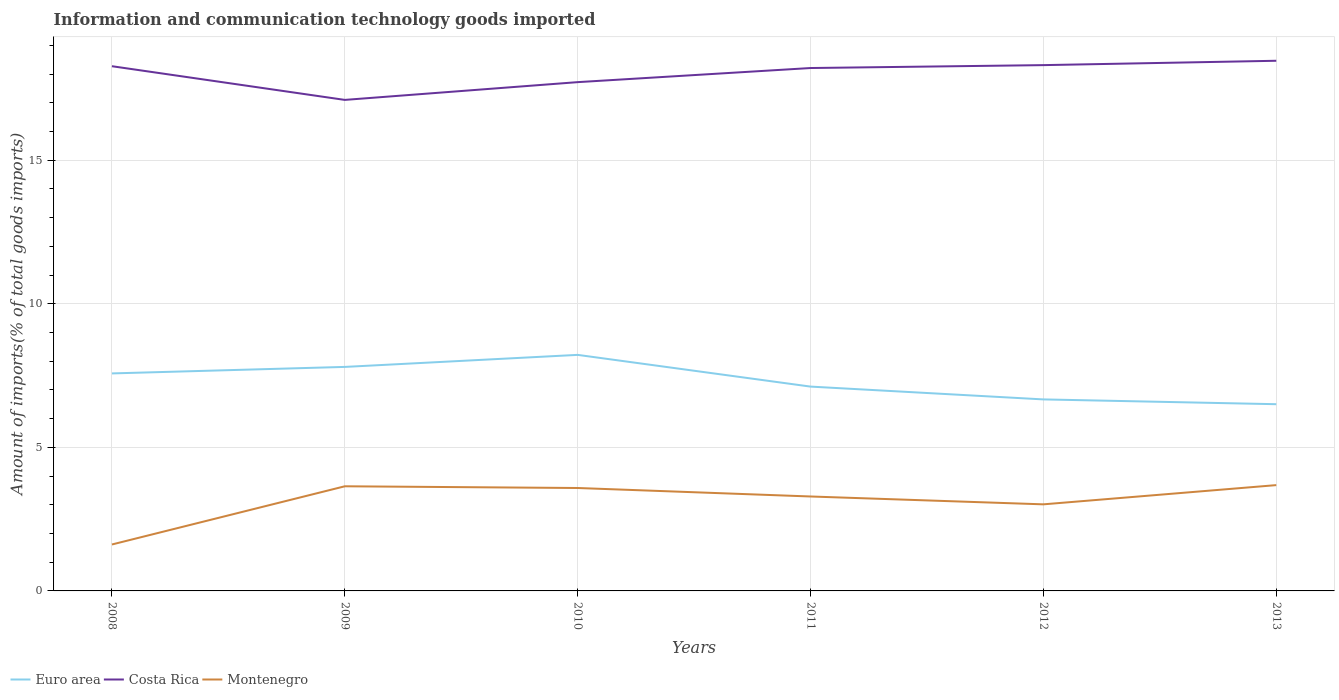How many different coloured lines are there?
Your response must be concise. 3. Does the line corresponding to Euro area intersect with the line corresponding to Costa Rica?
Make the answer very short. No. Across all years, what is the maximum amount of goods imported in Montenegro?
Give a very brief answer. 1.62. What is the total amount of goods imported in Montenegro in the graph?
Keep it short and to the point. 0.63. What is the difference between the highest and the second highest amount of goods imported in Montenegro?
Your answer should be compact. 2.07. Are the values on the major ticks of Y-axis written in scientific E-notation?
Offer a very short reply. No. Does the graph contain any zero values?
Ensure brevity in your answer.  No. Does the graph contain grids?
Provide a succinct answer. Yes. Where does the legend appear in the graph?
Your response must be concise. Bottom left. How are the legend labels stacked?
Provide a short and direct response. Horizontal. What is the title of the graph?
Give a very brief answer. Information and communication technology goods imported. Does "Guam" appear as one of the legend labels in the graph?
Provide a succinct answer. No. What is the label or title of the X-axis?
Keep it short and to the point. Years. What is the label or title of the Y-axis?
Give a very brief answer. Amount of imports(% of total goods imports). What is the Amount of imports(% of total goods imports) of Euro area in 2008?
Make the answer very short. 7.58. What is the Amount of imports(% of total goods imports) of Costa Rica in 2008?
Offer a very short reply. 18.28. What is the Amount of imports(% of total goods imports) in Montenegro in 2008?
Offer a very short reply. 1.62. What is the Amount of imports(% of total goods imports) of Euro area in 2009?
Your answer should be compact. 7.8. What is the Amount of imports(% of total goods imports) of Costa Rica in 2009?
Make the answer very short. 17.1. What is the Amount of imports(% of total goods imports) in Montenegro in 2009?
Your response must be concise. 3.64. What is the Amount of imports(% of total goods imports) in Euro area in 2010?
Your answer should be very brief. 8.22. What is the Amount of imports(% of total goods imports) in Costa Rica in 2010?
Keep it short and to the point. 17.72. What is the Amount of imports(% of total goods imports) of Montenegro in 2010?
Keep it short and to the point. 3.58. What is the Amount of imports(% of total goods imports) of Euro area in 2011?
Make the answer very short. 7.12. What is the Amount of imports(% of total goods imports) in Costa Rica in 2011?
Give a very brief answer. 18.21. What is the Amount of imports(% of total goods imports) in Montenegro in 2011?
Make the answer very short. 3.29. What is the Amount of imports(% of total goods imports) of Euro area in 2012?
Make the answer very short. 6.67. What is the Amount of imports(% of total goods imports) of Costa Rica in 2012?
Provide a short and direct response. 18.31. What is the Amount of imports(% of total goods imports) of Montenegro in 2012?
Provide a succinct answer. 3.02. What is the Amount of imports(% of total goods imports) of Euro area in 2013?
Offer a terse response. 6.5. What is the Amount of imports(% of total goods imports) of Costa Rica in 2013?
Offer a very short reply. 18.47. What is the Amount of imports(% of total goods imports) in Montenegro in 2013?
Keep it short and to the point. 3.69. Across all years, what is the maximum Amount of imports(% of total goods imports) of Euro area?
Give a very brief answer. 8.22. Across all years, what is the maximum Amount of imports(% of total goods imports) of Costa Rica?
Make the answer very short. 18.47. Across all years, what is the maximum Amount of imports(% of total goods imports) in Montenegro?
Ensure brevity in your answer.  3.69. Across all years, what is the minimum Amount of imports(% of total goods imports) of Euro area?
Ensure brevity in your answer.  6.5. Across all years, what is the minimum Amount of imports(% of total goods imports) of Costa Rica?
Your response must be concise. 17.1. Across all years, what is the minimum Amount of imports(% of total goods imports) in Montenegro?
Your answer should be compact. 1.62. What is the total Amount of imports(% of total goods imports) of Euro area in the graph?
Your answer should be very brief. 43.89. What is the total Amount of imports(% of total goods imports) of Costa Rica in the graph?
Keep it short and to the point. 108.1. What is the total Amount of imports(% of total goods imports) in Montenegro in the graph?
Give a very brief answer. 18.84. What is the difference between the Amount of imports(% of total goods imports) in Euro area in 2008 and that in 2009?
Offer a terse response. -0.23. What is the difference between the Amount of imports(% of total goods imports) of Costa Rica in 2008 and that in 2009?
Your answer should be very brief. 1.17. What is the difference between the Amount of imports(% of total goods imports) of Montenegro in 2008 and that in 2009?
Keep it short and to the point. -2.03. What is the difference between the Amount of imports(% of total goods imports) in Euro area in 2008 and that in 2010?
Make the answer very short. -0.65. What is the difference between the Amount of imports(% of total goods imports) in Costa Rica in 2008 and that in 2010?
Offer a very short reply. 0.55. What is the difference between the Amount of imports(% of total goods imports) in Montenegro in 2008 and that in 2010?
Make the answer very short. -1.97. What is the difference between the Amount of imports(% of total goods imports) in Euro area in 2008 and that in 2011?
Provide a succinct answer. 0.46. What is the difference between the Amount of imports(% of total goods imports) of Costa Rica in 2008 and that in 2011?
Keep it short and to the point. 0.06. What is the difference between the Amount of imports(% of total goods imports) in Montenegro in 2008 and that in 2011?
Your response must be concise. -1.67. What is the difference between the Amount of imports(% of total goods imports) in Euro area in 2008 and that in 2012?
Your answer should be very brief. 0.91. What is the difference between the Amount of imports(% of total goods imports) in Costa Rica in 2008 and that in 2012?
Give a very brief answer. -0.04. What is the difference between the Amount of imports(% of total goods imports) in Montenegro in 2008 and that in 2012?
Provide a succinct answer. -1.4. What is the difference between the Amount of imports(% of total goods imports) in Euro area in 2008 and that in 2013?
Provide a short and direct response. 1.07. What is the difference between the Amount of imports(% of total goods imports) in Costa Rica in 2008 and that in 2013?
Keep it short and to the point. -0.19. What is the difference between the Amount of imports(% of total goods imports) in Montenegro in 2008 and that in 2013?
Ensure brevity in your answer.  -2.07. What is the difference between the Amount of imports(% of total goods imports) of Euro area in 2009 and that in 2010?
Your answer should be compact. -0.42. What is the difference between the Amount of imports(% of total goods imports) of Costa Rica in 2009 and that in 2010?
Offer a very short reply. -0.62. What is the difference between the Amount of imports(% of total goods imports) of Montenegro in 2009 and that in 2010?
Ensure brevity in your answer.  0.06. What is the difference between the Amount of imports(% of total goods imports) of Euro area in 2009 and that in 2011?
Your answer should be compact. 0.69. What is the difference between the Amount of imports(% of total goods imports) in Costa Rica in 2009 and that in 2011?
Give a very brief answer. -1.11. What is the difference between the Amount of imports(% of total goods imports) in Montenegro in 2009 and that in 2011?
Provide a short and direct response. 0.35. What is the difference between the Amount of imports(% of total goods imports) in Euro area in 2009 and that in 2012?
Provide a short and direct response. 1.13. What is the difference between the Amount of imports(% of total goods imports) of Costa Rica in 2009 and that in 2012?
Make the answer very short. -1.21. What is the difference between the Amount of imports(% of total goods imports) of Montenegro in 2009 and that in 2012?
Keep it short and to the point. 0.63. What is the difference between the Amount of imports(% of total goods imports) of Euro area in 2009 and that in 2013?
Provide a succinct answer. 1.3. What is the difference between the Amount of imports(% of total goods imports) in Costa Rica in 2009 and that in 2013?
Keep it short and to the point. -1.36. What is the difference between the Amount of imports(% of total goods imports) in Montenegro in 2009 and that in 2013?
Your answer should be compact. -0.04. What is the difference between the Amount of imports(% of total goods imports) in Euro area in 2010 and that in 2011?
Your response must be concise. 1.1. What is the difference between the Amount of imports(% of total goods imports) in Costa Rica in 2010 and that in 2011?
Provide a succinct answer. -0.49. What is the difference between the Amount of imports(% of total goods imports) of Montenegro in 2010 and that in 2011?
Offer a very short reply. 0.3. What is the difference between the Amount of imports(% of total goods imports) in Euro area in 2010 and that in 2012?
Keep it short and to the point. 1.55. What is the difference between the Amount of imports(% of total goods imports) in Costa Rica in 2010 and that in 2012?
Offer a very short reply. -0.59. What is the difference between the Amount of imports(% of total goods imports) in Montenegro in 2010 and that in 2012?
Ensure brevity in your answer.  0.57. What is the difference between the Amount of imports(% of total goods imports) in Euro area in 2010 and that in 2013?
Make the answer very short. 1.72. What is the difference between the Amount of imports(% of total goods imports) of Costa Rica in 2010 and that in 2013?
Keep it short and to the point. -0.74. What is the difference between the Amount of imports(% of total goods imports) of Montenegro in 2010 and that in 2013?
Offer a very short reply. -0.1. What is the difference between the Amount of imports(% of total goods imports) in Euro area in 2011 and that in 2012?
Make the answer very short. 0.45. What is the difference between the Amount of imports(% of total goods imports) in Costa Rica in 2011 and that in 2012?
Your answer should be very brief. -0.1. What is the difference between the Amount of imports(% of total goods imports) in Montenegro in 2011 and that in 2012?
Offer a terse response. 0.27. What is the difference between the Amount of imports(% of total goods imports) of Euro area in 2011 and that in 2013?
Your response must be concise. 0.61. What is the difference between the Amount of imports(% of total goods imports) of Costa Rica in 2011 and that in 2013?
Provide a short and direct response. -0.25. What is the difference between the Amount of imports(% of total goods imports) in Montenegro in 2011 and that in 2013?
Provide a succinct answer. -0.4. What is the difference between the Amount of imports(% of total goods imports) in Euro area in 2012 and that in 2013?
Provide a short and direct response. 0.17. What is the difference between the Amount of imports(% of total goods imports) of Costa Rica in 2012 and that in 2013?
Provide a succinct answer. -0.15. What is the difference between the Amount of imports(% of total goods imports) of Montenegro in 2012 and that in 2013?
Offer a terse response. -0.67. What is the difference between the Amount of imports(% of total goods imports) of Euro area in 2008 and the Amount of imports(% of total goods imports) of Costa Rica in 2009?
Keep it short and to the point. -9.53. What is the difference between the Amount of imports(% of total goods imports) in Euro area in 2008 and the Amount of imports(% of total goods imports) in Montenegro in 2009?
Provide a succinct answer. 3.93. What is the difference between the Amount of imports(% of total goods imports) in Costa Rica in 2008 and the Amount of imports(% of total goods imports) in Montenegro in 2009?
Keep it short and to the point. 14.63. What is the difference between the Amount of imports(% of total goods imports) of Euro area in 2008 and the Amount of imports(% of total goods imports) of Costa Rica in 2010?
Offer a very short reply. -10.15. What is the difference between the Amount of imports(% of total goods imports) of Euro area in 2008 and the Amount of imports(% of total goods imports) of Montenegro in 2010?
Provide a short and direct response. 3.99. What is the difference between the Amount of imports(% of total goods imports) in Costa Rica in 2008 and the Amount of imports(% of total goods imports) in Montenegro in 2010?
Ensure brevity in your answer.  14.69. What is the difference between the Amount of imports(% of total goods imports) in Euro area in 2008 and the Amount of imports(% of total goods imports) in Costa Rica in 2011?
Your answer should be compact. -10.64. What is the difference between the Amount of imports(% of total goods imports) of Euro area in 2008 and the Amount of imports(% of total goods imports) of Montenegro in 2011?
Ensure brevity in your answer.  4.29. What is the difference between the Amount of imports(% of total goods imports) of Costa Rica in 2008 and the Amount of imports(% of total goods imports) of Montenegro in 2011?
Your answer should be compact. 14.99. What is the difference between the Amount of imports(% of total goods imports) in Euro area in 2008 and the Amount of imports(% of total goods imports) in Costa Rica in 2012?
Provide a succinct answer. -10.74. What is the difference between the Amount of imports(% of total goods imports) in Euro area in 2008 and the Amount of imports(% of total goods imports) in Montenegro in 2012?
Give a very brief answer. 4.56. What is the difference between the Amount of imports(% of total goods imports) in Costa Rica in 2008 and the Amount of imports(% of total goods imports) in Montenegro in 2012?
Offer a very short reply. 15.26. What is the difference between the Amount of imports(% of total goods imports) in Euro area in 2008 and the Amount of imports(% of total goods imports) in Costa Rica in 2013?
Your response must be concise. -10.89. What is the difference between the Amount of imports(% of total goods imports) in Euro area in 2008 and the Amount of imports(% of total goods imports) in Montenegro in 2013?
Your answer should be very brief. 3.89. What is the difference between the Amount of imports(% of total goods imports) of Costa Rica in 2008 and the Amount of imports(% of total goods imports) of Montenegro in 2013?
Offer a terse response. 14.59. What is the difference between the Amount of imports(% of total goods imports) in Euro area in 2009 and the Amount of imports(% of total goods imports) in Costa Rica in 2010?
Ensure brevity in your answer.  -9.92. What is the difference between the Amount of imports(% of total goods imports) in Euro area in 2009 and the Amount of imports(% of total goods imports) in Montenegro in 2010?
Ensure brevity in your answer.  4.22. What is the difference between the Amount of imports(% of total goods imports) of Costa Rica in 2009 and the Amount of imports(% of total goods imports) of Montenegro in 2010?
Your response must be concise. 13.52. What is the difference between the Amount of imports(% of total goods imports) in Euro area in 2009 and the Amount of imports(% of total goods imports) in Costa Rica in 2011?
Provide a succinct answer. -10.41. What is the difference between the Amount of imports(% of total goods imports) of Euro area in 2009 and the Amount of imports(% of total goods imports) of Montenegro in 2011?
Give a very brief answer. 4.51. What is the difference between the Amount of imports(% of total goods imports) of Costa Rica in 2009 and the Amount of imports(% of total goods imports) of Montenegro in 2011?
Provide a short and direct response. 13.81. What is the difference between the Amount of imports(% of total goods imports) of Euro area in 2009 and the Amount of imports(% of total goods imports) of Costa Rica in 2012?
Provide a short and direct response. -10.51. What is the difference between the Amount of imports(% of total goods imports) of Euro area in 2009 and the Amount of imports(% of total goods imports) of Montenegro in 2012?
Your answer should be very brief. 4.79. What is the difference between the Amount of imports(% of total goods imports) in Costa Rica in 2009 and the Amount of imports(% of total goods imports) in Montenegro in 2012?
Your answer should be compact. 14.09. What is the difference between the Amount of imports(% of total goods imports) of Euro area in 2009 and the Amount of imports(% of total goods imports) of Costa Rica in 2013?
Give a very brief answer. -10.66. What is the difference between the Amount of imports(% of total goods imports) of Euro area in 2009 and the Amount of imports(% of total goods imports) of Montenegro in 2013?
Offer a terse response. 4.12. What is the difference between the Amount of imports(% of total goods imports) in Costa Rica in 2009 and the Amount of imports(% of total goods imports) in Montenegro in 2013?
Your response must be concise. 13.42. What is the difference between the Amount of imports(% of total goods imports) in Euro area in 2010 and the Amount of imports(% of total goods imports) in Costa Rica in 2011?
Give a very brief answer. -9.99. What is the difference between the Amount of imports(% of total goods imports) in Euro area in 2010 and the Amount of imports(% of total goods imports) in Montenegro in 2011?
Provide a succinct answer. 4.93. What is the difference between the Amount of imports(% of total goods imports) in Costa Rica in 2010 and the Amount of imports(% of total goods imports) in Montenegro in 2011?
Offer a very short reply. 14.43. What is the difference between the Amount of imports(% of total goods imports) in Euro area in 2010 and the Amount of imports(% of total goods imports) in Costa Rica in 2012?
Ensure brevity in your answer.  -10.09. What is the difference between the Amount of imports(% of total goods imports) of Euro area in 2010 and the Amount of imports(% of total goods imports) of Montenegro in 2012?
Provide a succinct answer. 5.21. What is the difference between the Amount of imports(% of total goods imports) of Costa Rica in 2010 and the Amount of imports(% of total goods imports) of Montenegro in 2012?
Provide a succinct answer. 14.71. What is the difference between the Amount of imports(% of total goods imports) of Euro area in 2010 and the Amount of imports(% of total goods imports) of Costa Rica in 2013?
Offer a terse response. -10.24. What is the difference between the Amount of imports(% of total goods imports) in Euro area in 2010 and the Amount of imports(% of total goods imports) in Montenegro in 2013?
Give a very brief answer. 4.54. What is the difference between the Amount of imports(% of total goods imports) of Costa Rica in 2010 and the Amount of imports(% of total goods imports) of Montenegro in 2013?
Your answer should be compact. 14.04. What is the difference between the Amount of imports(% of total goods imports) of Euro area in 2011 and the Amount of imports(% of total goods imports) of Costa Rica in 2012?
Make the answer very short. -11.2. What is the difference between the Amount of imports(% of total goods imports) of Euro area in 2011 and the Amount of imports(% of total goods imports) of Montenegro in 2012?
Provide a short and direct response. 4.1. What is the difference between the Amount of imports(% of total goods imports) in Costa Rica in 2011 and the Amount of imports(% of total goods imports) in Montenegro in 2012?
Offer a terse response. 15.2. What is the difference between the Amount of imports(% of total goods imports) in Euro area in 2011 and the Amount of imports(% of total goods imports) in Costa Rica in 2013?
Your answer should be very brief. -11.35. What is the difference between the Amount of imports(% of total goods imports) in Euro area in 2011 and the Amount of imports(% of total goods imports) in Montenegro in 2013?
Your response must be concise. 3.43. What is the difference between the Amount of imports(% of total goods imports) of Costa Rica in 2011 and the Amount of imports(% of total goods imports) of Montenegro in 2013?
Offer a very short reply. 14.53. What is the difference between the Amount of imports(% of total goods imports) in Euro area in 2012 and the Amount of imports(% of total goods imports) in Costa Rica in 2013?
Your answer should be very brief. -11.8. What is the difference between the Amount of imports(% of total goods imports) of Euro area in 2012 and the Amount of imports(% of total goods imports) of Montenegro in 2013?
Keep it short and to the point. 2.99. What is the difference between the Amount of imports(% of total goods imports) in Costa Rica in 2012 and the Amount of imports(% of total goods imports) in Montenegro in 2013?
Your answer should be very brief. 14.63. What is the average Amount of imports(% of total goods imports) in Euro area per year?
Give a very brief answer. 7.32. What is the average Amount of imports(% of total goods imports) of Costa Rica per year?
Provide a short and direct response. 18.02. What is the average Amount of imports(% of total goods imports) of Montenegro per year?
Make the answer very short. 3.14. In the year 2008, what is the difference between the Amount of imports(% of total goods imports) of Euro area and Amount of imports(% of total goods imports) of Costa Rica?
Provide a succinct answer. -10.7. In the year 2008, what is the difference between the Amount of imports(% of total goods imports) in Euro area and Amount of imports(% of total goods imports) in Montenegro?
Provide a succinct answer. 5.96. In the year 2008, what is the difference between the Amount of imports(% of total goods imports) in Costa Rica and Amount of imports(% of total goods imports) in Montenegro?
Provide a short and direct response. 16.66. In the year 2009, what is the difference between the Amount of imports(% of total goods imports) of Euro area and Amount of imports(% of total goods imports) of Costa Rica?
Make the answer very short. -9.3. In the year 2009, what is the difference between the Amount of imports(% of total goods imports) in Euro area and Amount of imports(% of total goods imports) in Montenegro?
Your answer should be very brief. 4.16. In the year 2009, what is the difference between the Amount of imports(% of total goods imports) of Costa Rica and Amount of imports(% of total goods imports) of Montenegro?
Give a very brief answer. 13.46. In the year 2010, what is the difference between the Amount of imports(% of total goods imports) in Euro area and Amount of imports(% of total goods imports) in Costa Rica?
Give a very brief answer. -9.5. In the year 2010, what is the difference between the Amount of imports(% of total goods imports) of Euro area and Amount of imports(% of total goods imports) of Montenegro?
Make the answer very short. 4.64. In the year 2010, what is the difference between the Amount of imports(% of total goods imports) of Costa Rica and Amount of imports(% of total goods imports) of Montenegro?
Give a very brief answer. 14.14. In the year 2011, what is the difference between the Amount of imports(% of total goods imports) of Euro area and Amount of imports(% of total goods imports) of Costa Rica?
Your answer should be very brief. -11.1. In the year 2011, what is the difference between the Amount of imports(% of total goods imports) in Euro area and Amount of imports(% of total goods imports) in Montenegro?
Make the answer very short. 3.83. In the year 2011, what is the difference between the Amount of imports(% of total goods imports) of Costa Rica and Amount of imports(% of total goods imports) of Montenegro?
Provide a short and direct response. 14.92. In the year 2012, what is the difference between the Amount of imports(% of total goods imports) in Euro area and Amount of imports(% of total goods imports) in Costa Rica?
Give a very brief answer. -11.64. In the year 2012, what is the difference between the Amount of imports(% of total goods imports) of Euro area and Amount of imports(% of total goods imports) of Montenegro?
Offer a terse response. 3.65. In the year 2012, what is the difference between the Amount of imports(% of total goods imports) in Costa Rica and Amount of imports(% of total goods imports) in Montenegro?
Give a very brief answer. 15.3. In the year 2013, what is the difference between the Amount of imports(% of total goods imports) in Euro area and Amount of imports(% of total goods imports) in Costa Rica?
Provide a succinct answer. -11.96. In the year 2013, what is the difference between the Amount of imports(% of total goods imports) of Euro area and Amount of imports(% of total goods imports) of Montenegro?
Keep it short and to the point. 2.82. In the year 2013, what is the difference between the Amount of imports(% of total goods imports) in Costa Rica and Amount of imports(% of total goods imports) in Montenegro?
Your response must be concise. 14.78. What is the ratio of the Amount of imports(% of total goods imports) of Euro area in 2008 to that in 2009?
Your response must be concise. 0.97. What is the ratio of the Amount of imports(% of total goods imports) in Costa Rica in 2008 to that in 2009?
Keep it short and to the point. 1.07. What is the ratio of the Amount of imports(% of total goods imports) in Montenegro in 2008 to that in 2009?
Your answer should be very brief. 0.44. What is the ratio of the Amount of imports(% of total goods imports) in Euro area in 2008 to that in 2010?
Offer a terse response. 0.92. What is the ratio of the Amount of imports(% of total goods imports) of Costa Rica in 2008 to that in 2010?
Make the answer very short. 1.03. What is the ratio of the Amount of imports(% of total goods imports) in Montenegro in 2008 to that in 2010?
Provide a short and direct response. 0.45. What is the ratio of the Amount of imports(% of total goods imports) in Euro area in 2008 to that in 2011?
Give a very brief answer. 1.06. What is the ratio of the Amount of imports(% of total goods imports) of Montenegro in 2008 to that in 2011?
Keep it short and to the point. 0.49. What is the ratio of the Amount of imports(% of total goods imports) in Euro area in 2008 to that in 2012?
Your answer should be very brief. 1.14. What is the ratio of the Amount of imports(% of total goods imports) in Costa Rica in 2008 to that in 2012?
Your response must be concise. 1. What is the ratio of the Amount of imports(% of total goods imports) in Montenegro in 2008 to that in 2012?
Your response must be concise. 0.54. What is the ratio of the Amount of imports(% of total goods imports) of Euro area in 2008 to that in 2013?
Ensure brevity in your answer.  1.16. What is the ratio of the Amount of imports(% of total goods imports) in Costa Rica in 2008 to that in 2013?
Provide a succinct answer. 0.99. What is the ratio of the Amount of imports(% of total goods imports) of Montenegro in 2008 to that in 2013?
Provide a short and direct response. 0.44. What is the ratio of the Amount of imports(% of total goods imports) in Euro area in 2009 to that in 2010?
Your answer should be compact. 0.95. What is the ratio of the Amount of imports(% of total goods imports) of Costa Rica in 2009 to that in 2010?
Keep it short and to the point. 0.97. What is the ratio of the Amount of imports(% of total goods imports) of Montenegro in 2009 to that in 2010?
Offer a very short reply. 1.02. What is the ratio of the Amount of imports(% of total goods imports) in Euro area in 2009 to that in 2011?
Make the answer very short. 1.1. What is the ratio of the Amount of imports(% of total goods imports) in Costa Rica in 2009 to that in 2011?
Your answer should be compact. 0.94. What is the ratio of the Amount of imports(% of total goods imports) in Montenegro in 2009 to that in 2011?
Make the answer very short. 1.11. What is the ratio of the Amount of imports(% of total goods imports) in Euro area in 2009 to that in 2012?
Provide a succinct answer. 1.17. What is the ratio of the Amount of imports(% of total goods imports) in Costa Rica in 2009 to that in 2012?
Provide a short and direct response. 0.93. What is the ratio of the Amount of imports(% of total goods imports) in Montenegro in 2009 to that in 2012?
Provide a short and direct response. 1.21. What is the ratio of the Amount of imports(% of total goods imports) in Euro area in 2009 to that in 2013?
Make the answer very short. 1.2. What is the ratio of the Amount of imports(% of total goods imports) in Costa Rica in 2009 to that in 2013?
Make the answer very short. 0.93. What is the ratio of the Amount of imports(% of total goods imports) in Montenegro in 2009 to that in 2013?
Provide a short and direct response. 0.99. What is the ratio of the Amount of imports(% of total goods imports) of Euro area in 2010 to that in 2011?
Give a very brief answer. 1.16. What is the ratio of the Amount of imports(% of total goods imports) of Montenegro in 2010 to that in 2011?
Keep it short and to the point. 1.09. What is the ratio of the Amount of imports(% of total goods imports) of Euro area in 2010 to that in 2012?
Your response must be concise. 1.23. What is the ratio of the Amount of imports(% of total goods imports) of Costa Rica in 2010 to that in 2012?
Ensure brevity in your answer.  0.97. What is the ratio of the Amount of imports(% of total goods imports) in Montenegro in 2010 to that in 2012?
Keep it short and to the point. 1.19. What is the ratio of the Amount of imports(% of total goods imports) in Euro area in 2010 to that in 2013?
Provide a succinct answer. 1.26. What is the ratio of the Amount of imports(% of total goods imports) of Costa Rica in 2010 to that in 2013?
Provide a short and direct response. 0.96. What is the ratio of the Amount of imports(% of total goods imports) in Montenegro in 2010 to that in 2013?
Make the answer very short. 0.97. What is the ratio of the Amount of imports(% of total goods imports) in Euro area in 2011 to that in 2012?
Provide a short and direct response. 1.07. What is the ratio of the Amount of imports(% of total goods imports) of Montenegro in 2011 to that in 2012?
Offer a terse response. 1.09. What is the ratio of the Amount of imports(% of total goods imports) of Euro area in 2011 to that in 2013?
Ensure brevity in your answer.  1.09. What is the ratio of the Amount of imports(% of total goods imports) in Costa Rica in 2011 to that in 2013?
Your answer should be compact. 0.99. What is the ratio of the Amount of imports(% of total goods imports) in Montenegro in 2011 to that in 2013?
Keep it short and to the point. 0.89. What is the ratio of the Amount of imports(% of total goods imports) of Euro area in 2012 to that in 2013?
Provide a short and direct response. 1.03. What is the ratio of the Amount of imports(% of total goods imports) of Costa Rica in 2012 to that in 2013?
Provide a short and direct response. 0.99. What is the ratio of the Amount of imports(% of total goods imports) of Montenegro in 2012 to that in 2013?
Give a very brief answer. 0.82. What is the difference between the highest and the second highest Amount of imports(% of total goods imports) in Euro area?
Offer a very short reply. 0.42. What is the difference between the highest and the second highest Amount of imports(% of total goods imports) of Costa Rica?
Make the answer very short. 0.15. What is the difference between the highest and the second highest Amount of imports(% of total goods imports) in Montenegro?
Keep it short and to the point. 0.04. What is the difference between the highest and the lowest Amount of imports(% of total goods imports) of Euro area?
Give a very brief answer. 1.72. What is the difference between the highest and the lowest Amount of imports(% of total goods imports) in Costa Rica?
Keep it short and to the point. 1.36. What is the difference between the highest and the lowest Amount of imports(% of total goods imports) of Montenegro?
Offer a very short reply. 2.07. 